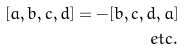<formula> <loc_0><loc_0><loc_500><loc_500>[ a , b , c , d ] = - [ b , c , d , a ] \\ e t c .</formula> 